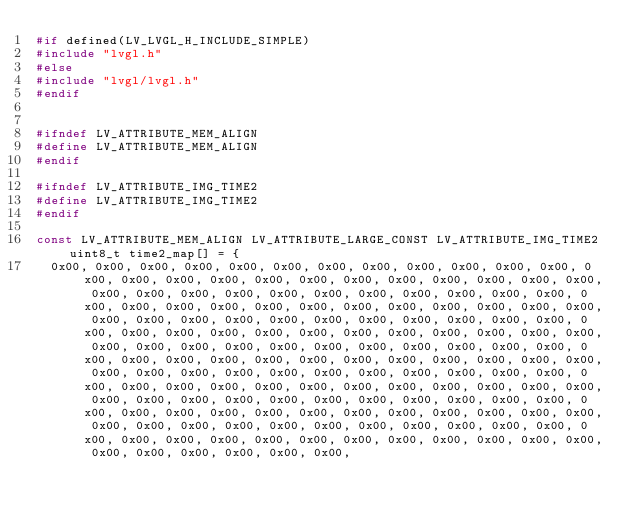Convert code to text. <code><loc_0><loc_0><loc_500><loc_500><_C_>#if defined(LV_LVGL_H_INCLUDE_SIMPLE)
#include "lvgl.h"
#else
#include "lvgl/lvgl.h"
#endif


#ifndef LV_ATTRIBUTE_MEM_ALIGN
#define LV_ATTRIBUTE_MEM_ALIGN
#endif

#ifndef LV_ATTRIBUTE_IMG_TIME2
#define LV_ATTRIBUTE_IMG_TIME2
#endif

const LV_ATTRIBUTE_MEM_ALIGN LV_ATTRIBUTE_LARGE_CONST LV_ATTRIBUTE_IMG_TIME2 uint8_t time2_map[] = {
  0x00, 0x00, 0x00, 0x00, 0x00, 0x00, 0x00, 0x00, 0x00, 0x00, 0x00, 0x00, 0x00, 0x00, 0x00, 0x00, 0x00, 0x00, 0x00, 0x00, 0x00, 0x00, 0x00, 0x00, 0x00, 0x00, 0x00, 0x00, 0x00, 0x00, 0x00, 0x00, 0x00, 0x00, 0x00, 0x00, 0x00, 0x00, 0x00, 0x00, 0x00, 0x00, 0x00, 0x00, 0x00, 0x00, 0x00, 0x00, 0x00, 0x00, 0x00, 0x00, 0x00, 0x00, 0x00, 0x00, 0x00, 0x00, 0x00, 0x00, 0x00, 0x00, 0x00, 0x00, 0x00, 0x00, 0x00, 0x00, 0x00, 0x00, 0x00, 0x00, 0x00, 0x00, 0x00, 0x00, 0x00, 0x00, 0x00, 0x00, 0x00, 0x00, 0x00, 0x00, 0x00, 0x00, 0x00, 0x00, 0x00, 0x00, 0x00, 0x00, 0x00, 0x00, 0x00, 0x00, 0x00, 0x00, 0x00, 0x00, 0x00, 0x00, 0x00, 0x00, 0x00, 0x00, 0x00, 0x00, 0x00, 0x00, 0x00, 0x00, 0x00, 0x00, 0x00, 0x00, 0x00, 0x00, 0x00, 0x00, 0x00, 0x00, 0x00, 0x00, 0x00, 0x00, 0x00, 0x00, 0x00, 0x00, 0x00, 0x00, 0x00, 0x00, 0x00, 0x00, 0x00, 0x00, 0x00, 0x00, 0x00, 0x00, 0x00, 0x00, 0x00, 0x00, 0x00, 0x00, 0x00, 0x00, 0x00, 0x00, 0x00, 0x00, 0x00, 0x00, 0x00, 0x00, 0x00, 0x00, 0x00, 0x00, 0x00, 0x00, 0x00, 0x00, 0x00, 0x00, </code> 